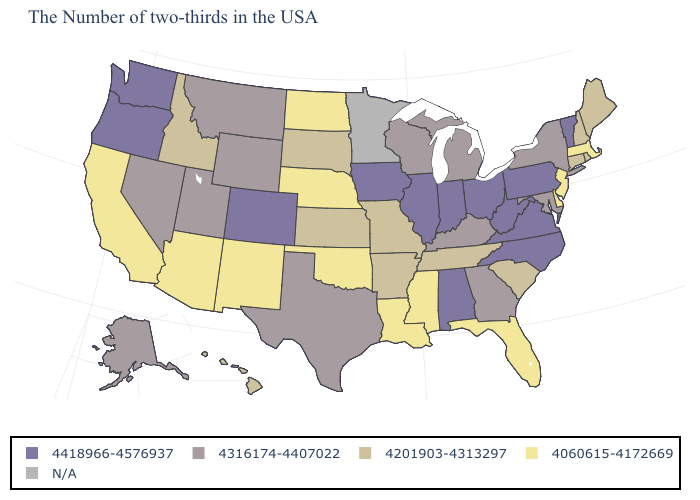What is the value of Oklahoma?
Answer briefly. 4060615-4172669. What is the value of Idaho?
Write a very short answer. 4201903-4313297. What is the highest value in states that border Massachusetts?
Write a very short answer. 4418966-4576937. What is the value of New Mexico?
Keep it brief. 4060615-4172669. Does the map have missing data?
Short answer required. Yes. Which states have the lowest value in the South?
Write a very short answer. Delaware, Florida, Mississippi, Louisiana, Oklahoma. What is the lowest value in the West?
Write a very short answer. 4060615-4172669. Among the states that border South Carolina , does North Carolina have the highest value?
Give a very brief answer. Yes. Which states hav the highest value in the Northeast?
Concise answer only. Vermont, Pennsylvania. Name the states that have a value in the range N/A?
Quick response, please. Minnesota. What is the lowest value in states that border Kansas?
Short answer required. 4060615-4172669. Among the states that border Alabama , which have the highest value?
Answer briefly. Georgia. What is the value of Ohio?
Short answer required. 4418966-4576937. Name the states that have a value in the range N/A?
Quick response, please. Minnesota. What is the lowest value in the South?
Keep it brief. 4060615-4172669. 